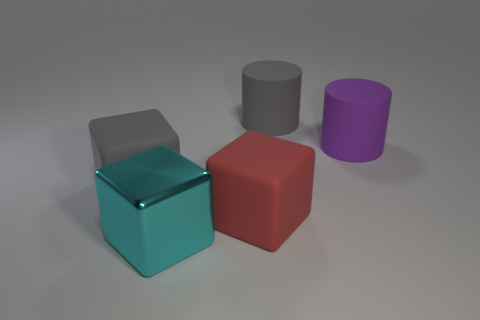The thing that is to the left of the red rubber object and behind the big red matte cube has what shape?
Make the answer very short. Cube. There is a large rubber thing in front of the big matte thing that is to the left of the metal block; what is its shape?
Provide a short and direct response. Cube. Is the red matte thing the same shape as the cyan thing?
Provide a succinct answer. Yes. There is a gray matte thing that is to the right of the matte cube left of the big red matte cube; how many big cyan metal blocks are behind it?
Offer a very short reply. 0. What is the shape of the large purple thing that is made of the same material as the gray cylinder?
Provide a short and direct response. Cylinder. What material is the large gray thing behind the big block behind the rubber cube in front of the gray matte block?
Provide a succinct answer. Rubber. What number of objects are cylinders that are behind the large purple thing or large metal things?
Your answer should be very brief. 2. How many other things are there of the same shape as the cyan metallic object?
Provide a succinct answer. 2. Is the number of big gray blocks that are right of the large gray rubber cylinder greater than the number of tiny blue metal balls?
Make the answer very short. No. There is a red rubber object that is the same shape as the big cyan metal object; what size is it?
Make the answer very short. Large. 